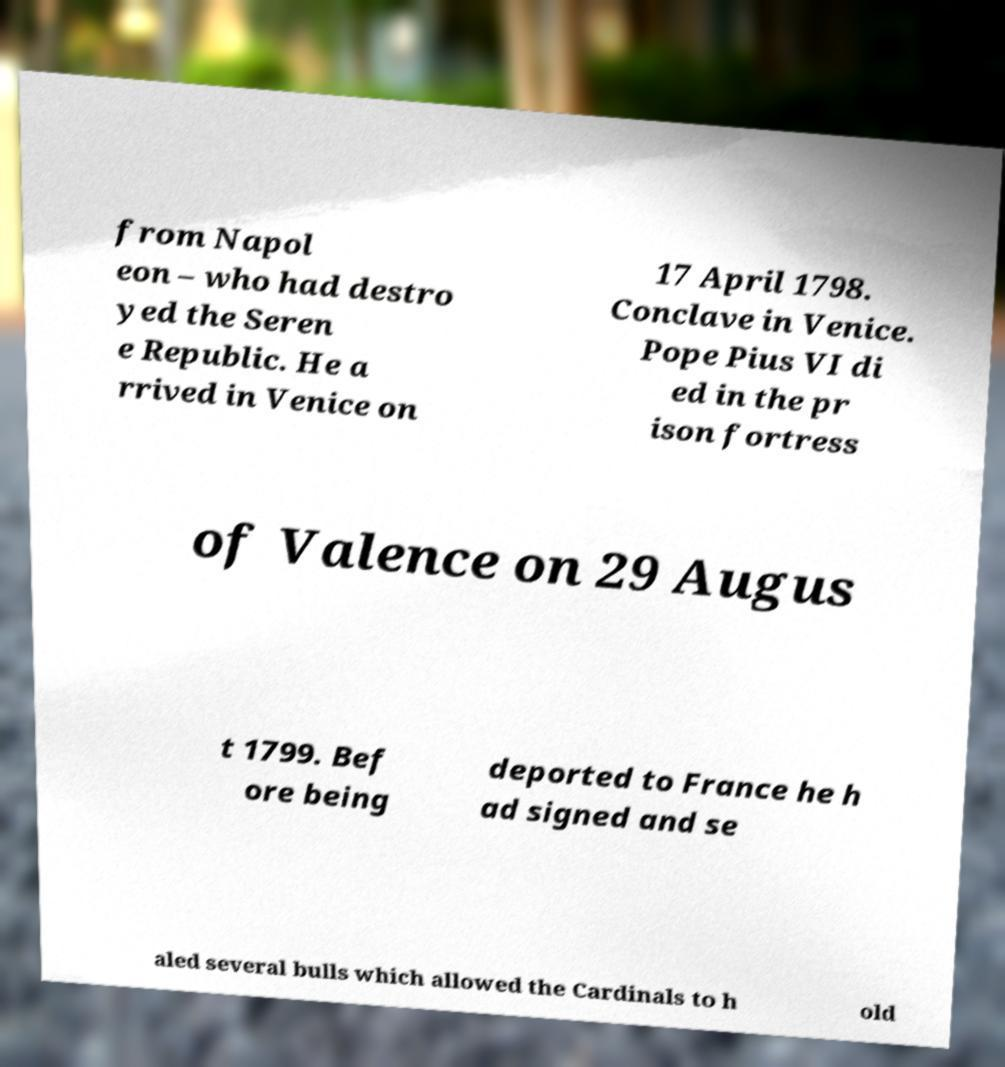There's text embedded in this image that I need extracted. Can you transcribe it verbatim? from Napol eon – who had destro yed the Seren e Republic. He a rrived in Venice on 17 April 1798. Conclave in Venice. Pope Pius VI di ed in the pr ison fortress of Valence on 29 Augus t 1799. Bef ore being deported to France he h ad signed and se aled several bulls which allowed the Cardinals to h old 